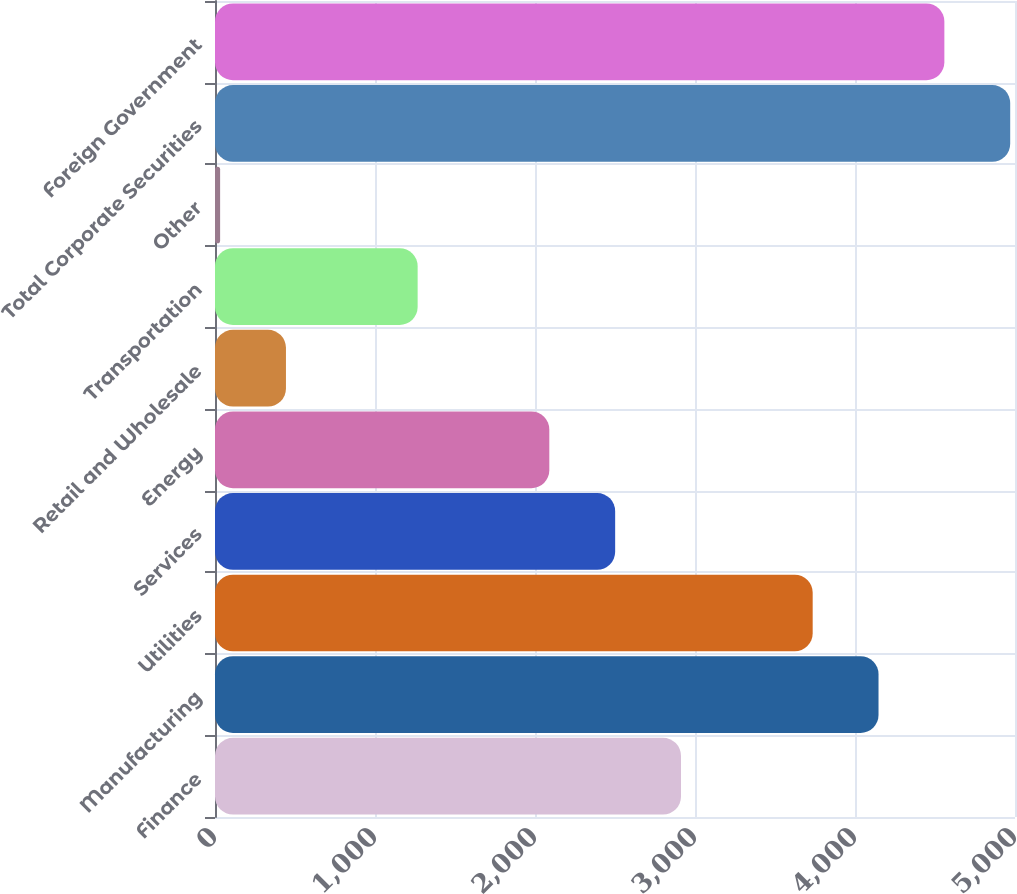Convert chart to OTSL. <chart><loc_0><loc_0><loc_500><loc_500><bar_chart><fcel>Finance<fcel>Manufacturing<fcel>Utilities<fcel>Services<fcel>Energy<fcel>Retail and Wholesale<fcel>Transportation<fcel>Other<fcel>Total Corporate Securities<fcel>Foreign Government<nl><fcel>2912.5<fcel>4147<fcel>3735.5<fcel>2501<fcel>2089.5<fcel>443.5<fcel>1266.5<fcel>32<fcel>4970<fcel>4558.5<nl></chart> 